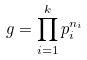<formula> <loc_0><loc_0><loc_500><loc_500>g = \prod _ { i = 1 } ^ { k } p _ { i } ^ { n _ { i } }</formula> 